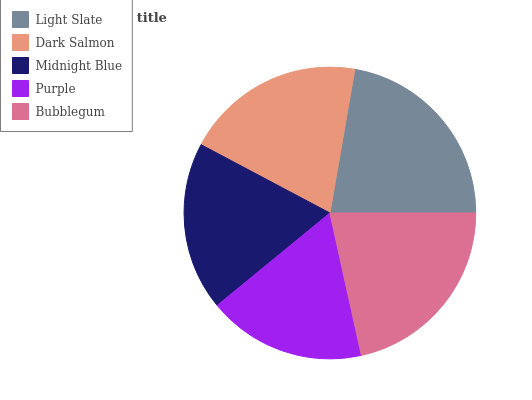Is Purple the minimum?
Answer yes or no. Yes. Is Light Slate the maximum?
Answer yes or no. Yes. Is Dark Salmon the minimum?
Answer yes or no. No. Is Dark Salmon the maximum?
Answer yes or no. No. Is Light Slate greater than Dark Salmon?
Answer yes or no. Yes. Is Dark Salmon less than Light Slate?
Answer yes or no. Yes. Is Dark Salmon greater than Light Slate?
Answer yes or no. No. Is Light Slate less than Dark Salmon?
Answer yes or no. No. Is Dark Salmon the high median?
Answer yes or no. Yes. Is Dark Salmon the low median?
Answer yes or no. Yes. Is Purple the high median?
Answer yes or no. No. Is Purple the low median?
Answer yes or no. No. 